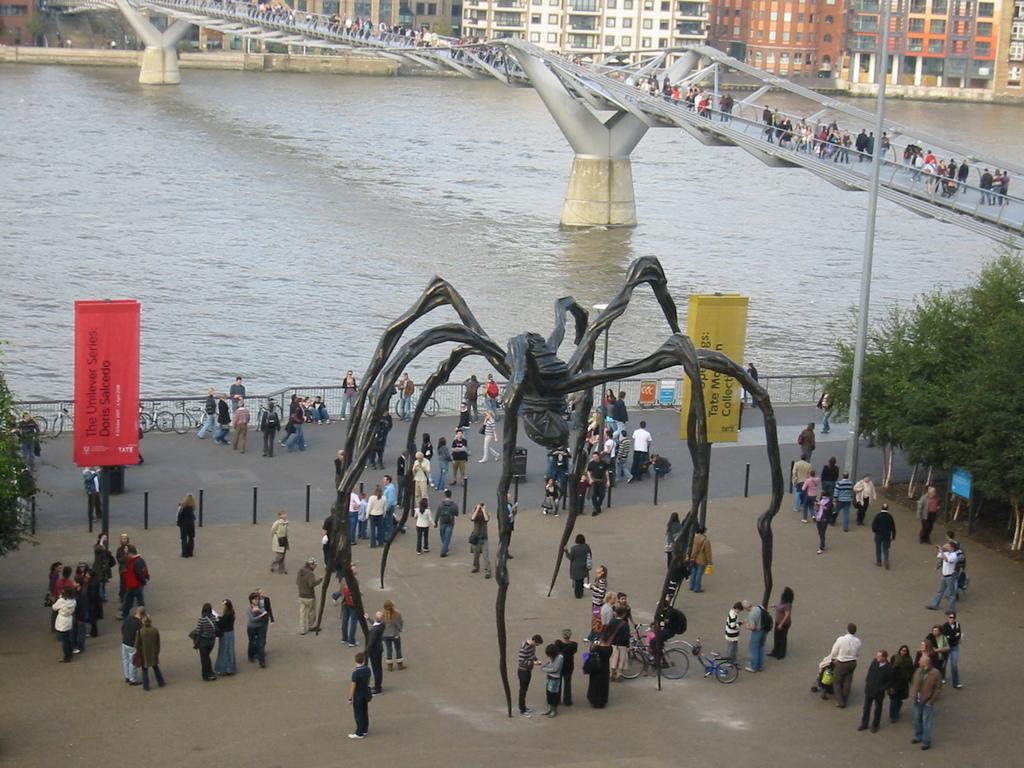Can you describe this image briefly? In this image there is a statue on the floor. Few persons are standing on the floor. Few persons are standing on the road. Few bicycles are kept near the fence. Few bicycles are kept near the statue. Right side there are few trees. Few persons are walking on the bridge which is over the water. Top of the image there are few buildings. 